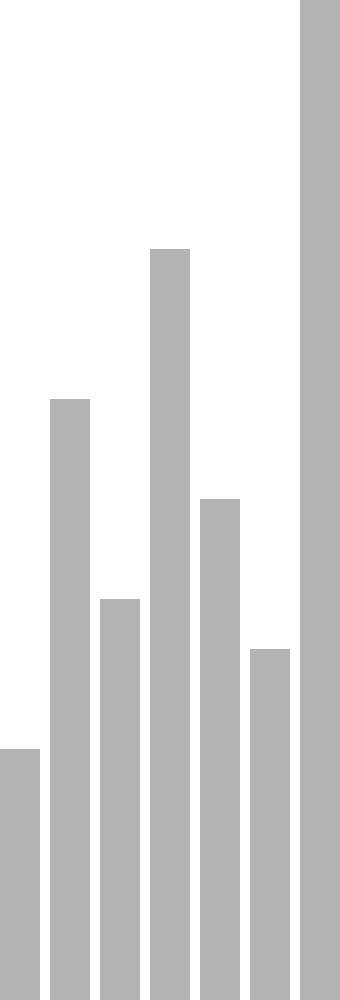As a mobile app developer for food truck ordering systems, you need to visualize wait times for different food trucks. The image shows three visualization techniques: a bar chart, a line graph, and a heat map. Which technique would be most effective for users to quickly identify the food truck with the shortest wait time, and why? To determine the most effective visualization technique for quickly identifying the food truck with the shortest wait time, let's analyze each method:

1. Bar Chart:
   - Provides a clear vertical representation of wait times
   - Easy to compare heights of bars
   - Allows for precise reading of wait time values

2. Line Graph:
   - Shows trends and patterns in wait times across food trucks
   - Useful for identifying overall fluctuations
   - Less effective for quick comparisons of individual values

3. Heat Map:
   - Uses color intensity to represent wait times
   - Provides a quick visual cue for longer vs. shorter wait times
   - Lacks precise numerical information

For the specific task of quickly identifying the shortest wait time:

- The bar chart is most effective because:
  a) It allows for easy visual comparison of heights
  b) The shortest bar is immediately apparent
  c) It provides precise wait time values

- The line graph is less effective because:
  a) It requires tracing the line to find the lowest point
  b) Comparison between points is not as intuitive as bar heights

- The heat map is moderately effective for quick identification but:
  a) Lacks precise numerical information
  b) Requires interpretation of color intensity

Therefore, the bar chart is the most effective visualization technique for quickly identifying the food truck with the shortest wait time.
Answer: Bar chart, due to easy visual comparison of heights and immediate identification of the shortest bar. 